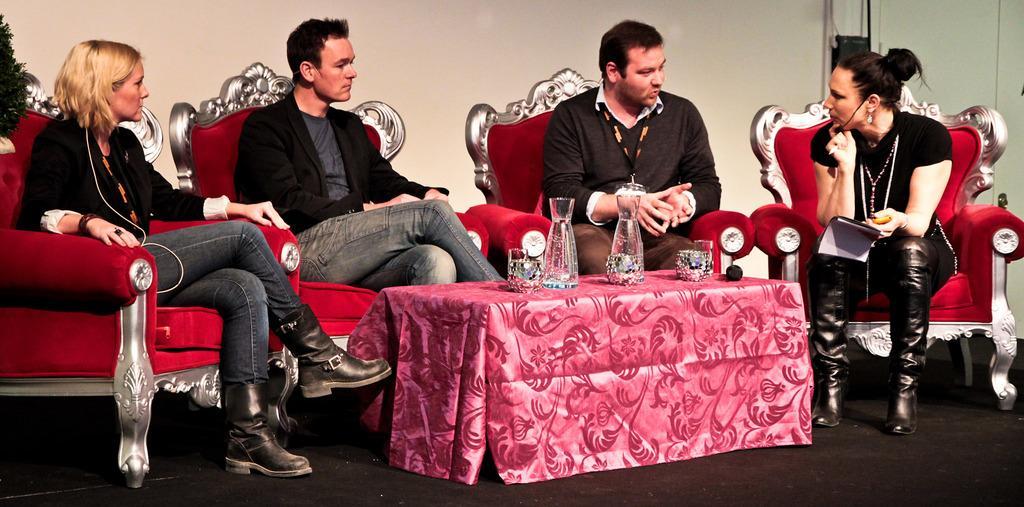Describe this image in one or two sentences. In the picture we can see two men and two women are sitting on the chairs which are red in color with some designs on it and in front of them, we can see a table with a pink color cloth with some designs on it and on it we can see some glasses. 